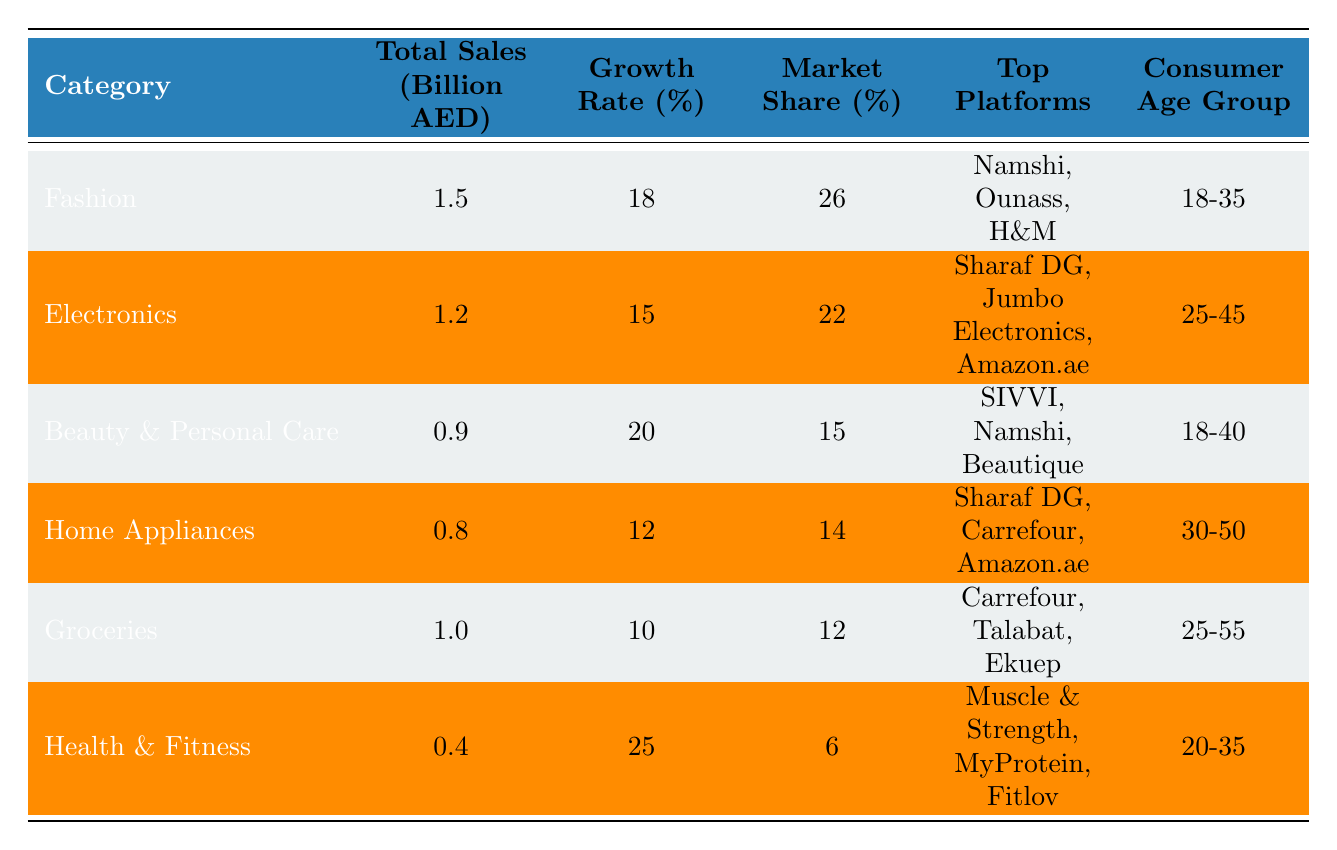What was the total sales for the Fashion category? The table indicates that the total sales for the Fashion category is listed as 1.5 billion AED.
Answer: 1.5 billion AED Which category has the highest market share? By comparing the market share percentages in the table, the Fashion category has the highest market share at 26%.
Answer: Fashion How many categories experienced a growth rate above 15%? The categories with growth rates above 15% are Fashion (18%), Beauty & Personal Care (20%), and Health & Fitness (25%). This totals three categories.
Answer: 3 What is the average total sales for all the categories? To find the average, we first sum the total sales: 1.5 + 1.2 + 0.9 + 0.8 + 1.0 + 0.4 = 5.0 billion AED. There are six categories, thus the average is 5.0 billion AED / 6 ≈ 0.833 billion AED.
Answer: 0.833 billion AED Is the total sales for Groceries less than that of Health & Fitness? The Groceries category has total sales of 1.0 billion AED while Health & Fitness has 0.4 billion AED, so the statement is true.
Answer: Yes Which age group is the consumer base for the Home Appliances category? The consumer age group for the Home Appliances category is 30-50 years as stated in the table.
Answer: 30-50 What is the total market share of the Electronics and Home Appliances categories combined? The market share for Electronics is 22% and for Home Appliances is 14%. Adding them together gives 22% + 14% = 36%.
Answer: 36% Which category had the lowest total sales, and what was its sales figure? The table shows that Health & Fitness had the lowest total sales at 0.4 billion AED.
Answer: Health & Fitness, 0.4 billion AED 